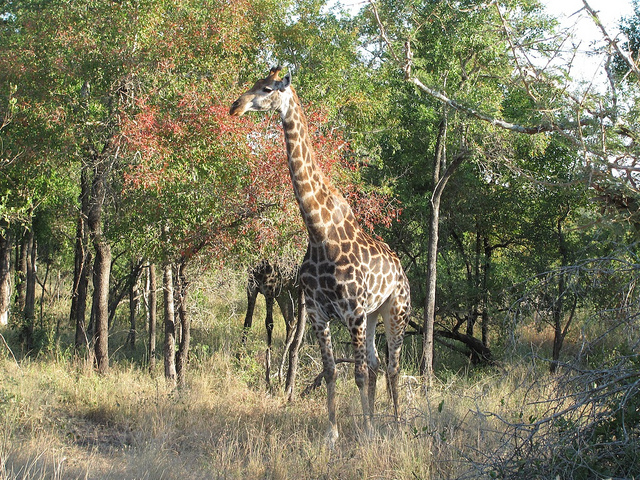How many giraffe are in the forest? 2 